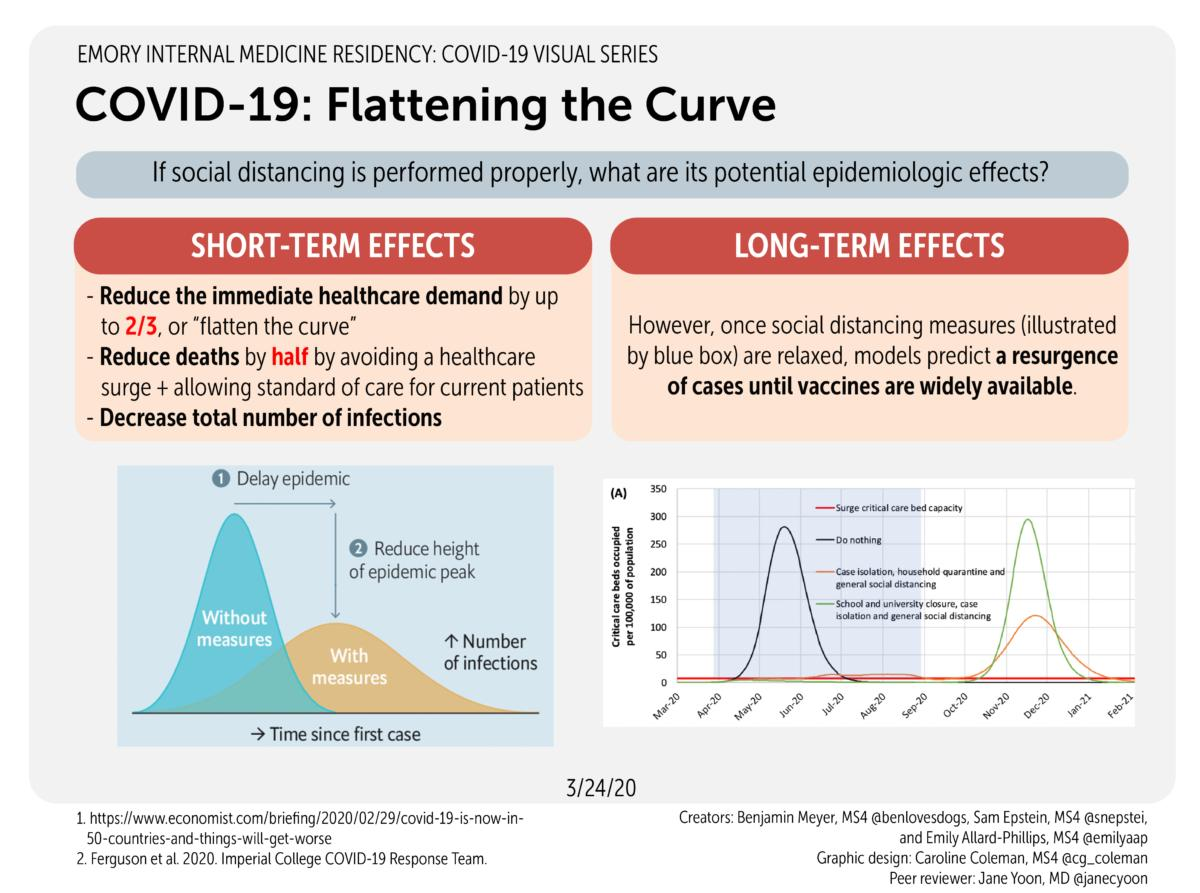Identify some key points in this picture. The curve that has the second highest peak is the one that should be performed. The social distancing approach, including measures such as reducing physical distance between individuals and increased social distancing measures, should be implemented to slow down the reporting of COVID-19 cases. If proper social distancing measures are implemented, only 0.3333...% of medical workers would be required. If mandated restrictions on social distancing are lifted, the number of infected individuals is likely to increase, as shown in the graph. Under the heading of Short-term effects, there are a total of 3 points listed. 